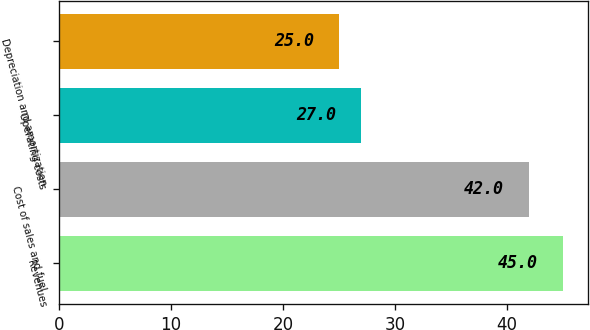<chart> <loc_0><loc_0><loc_500><loc_500><bar_chart><fcel>Revenues<fcel>Cost of sales and fuel<fcel>Operating costs<fcel>Depreciation and amortization<nl><fcel>45<fcel>42<fcel>27<fcel>25<nl></chart> 